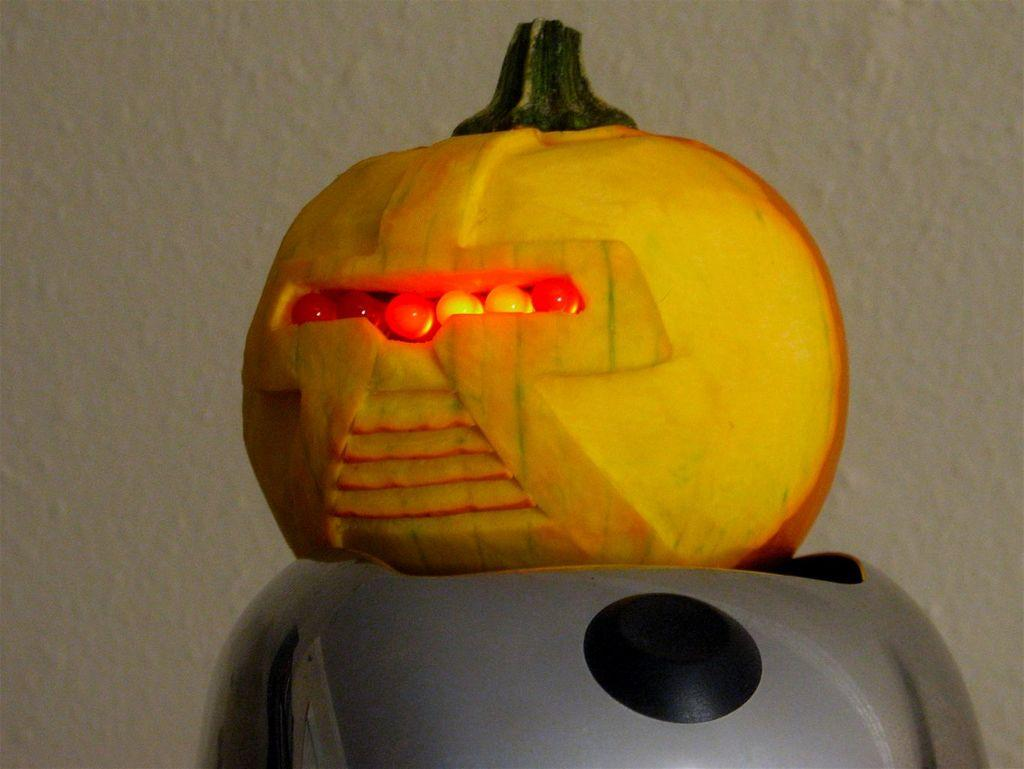What is the main subject of the image? The main subject of the image is a pumpkin carving. What colors can be seen on the object beneath the pumpkin carving? The object beneath the pumpkin carving has ash and black colors. Are there any other objects in the image besides the pumpkin carving? Yes, there are other objects in the image. What can be seen in the background of the image? The background of the image includes a wall. How many babies are visible in the image? There are no babies present in the image. Who is the creator of the pumpkin carving in the image? The image does not provide information about the creator of the pumpkin carving. 